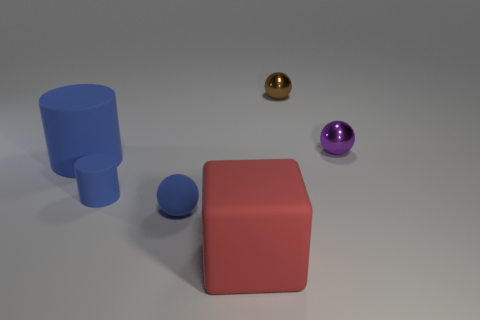There is a tiny sphere to the left of the brown sphere; is its color the same as the large cylinder?
Provide a succinct answer. Yes. How many other objects are there of the same color as the big rubber cylinder?
Ensure brevity in your answer.  2. There is a large object that is behind the matte sphere; is its color the same as the tiny object left of the small blue ball?
Offer a very short reply. Yes. There is another cylinder that is the same color as the big matte cylinder; what is it made of?
Provide a succinct answer. Rubber. Is the number of blue objects to the right of the purple metallic object less than the number of small metal balls to the right of the brown metal ball?
Provide a short and direct response. Yes. There is a shiny thing to the left of the object that is to the right of the metal object that is to the left of the purple shiny sphere; what shape is it?
Give a very brief answer. Sphere. There is a tiny thing that is both behind the small blue cylinder and in front of the brown sphere; what is its shape?
Offer a terse response. Sphere. Is there a small purple sphere made of the same material as the large cube?
Give a very brief answer. No. The other cylinder that is the same color as the tiny cylinder is what size?
Offer a very short reply. Large. There is a small sphere that is to the left of the small brown object; what is its color?
Give a very brief answer. Blue. 